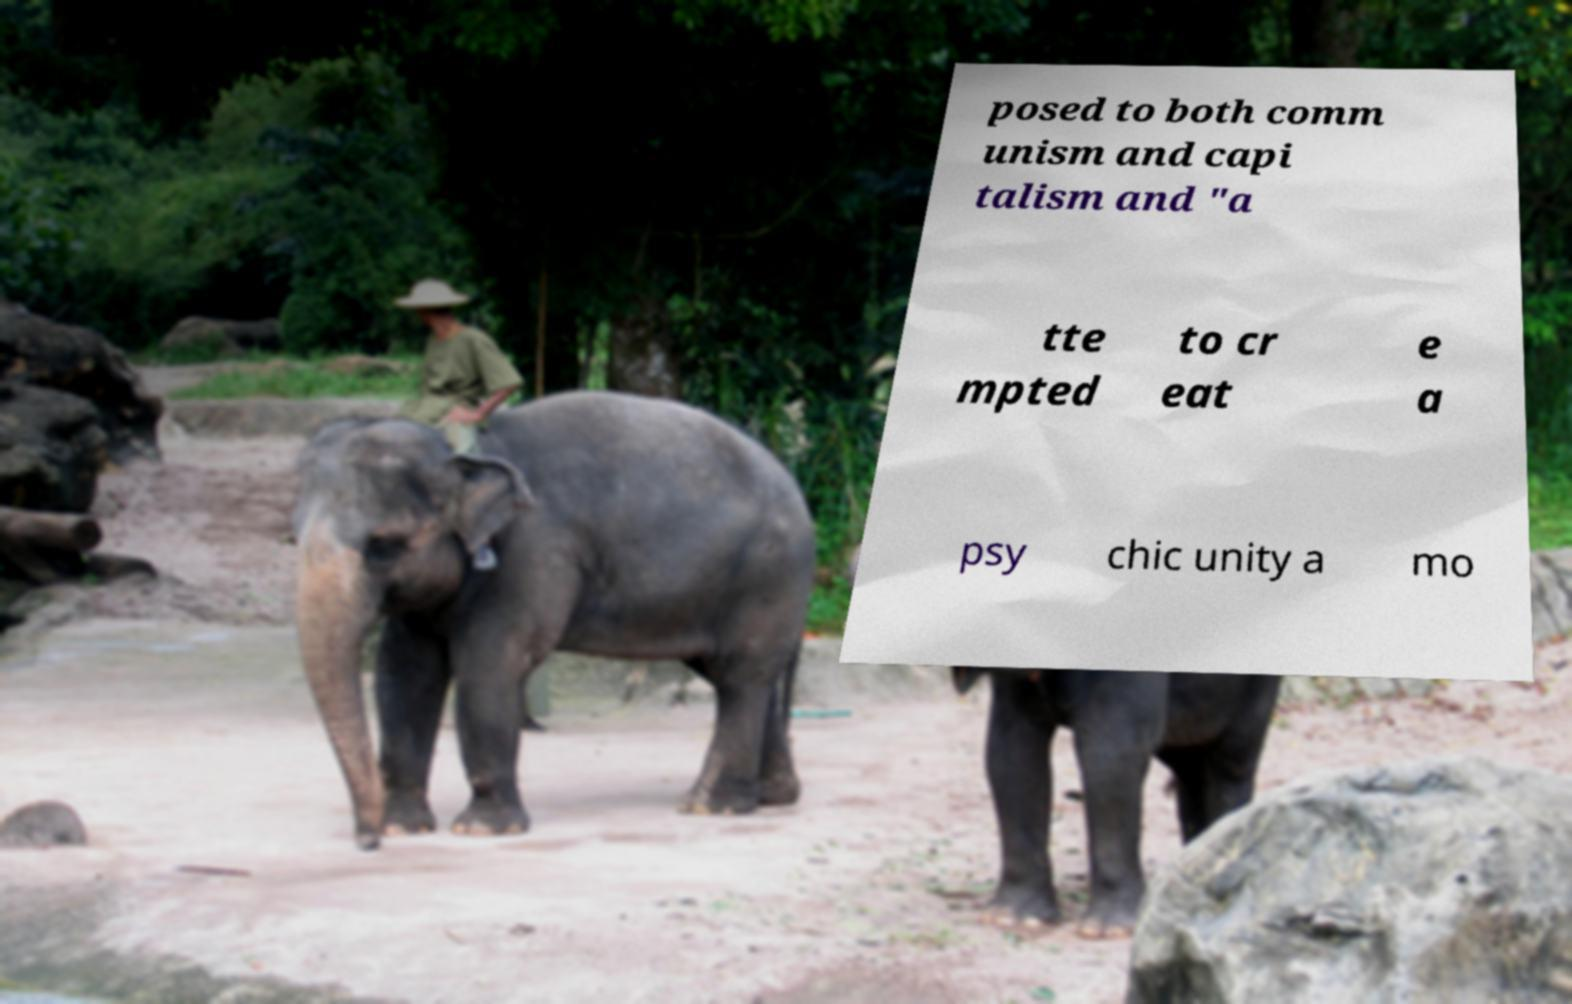I need the written content from this picture converted into text. Can you do that? posed to both comm unism and capi talism and "a tte mpted to cr eat e a psy chic unity a mo 